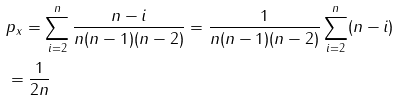Convert formula to latex. <formula><loc_0><loc_0><loc_500><loc_500>& p _ { x } = \sum _ { i = 2 } ^ { n } \frac { n - i } { n ( n - 1 ) ( n - 2 ) } = \frac { 1 } { n ( n - 1 ) ( n - 2 ) } \sum _ { i = 2 } ^ { n } ( n - i ) \\ & = \frac { 1 } { 2 n }</formula> 